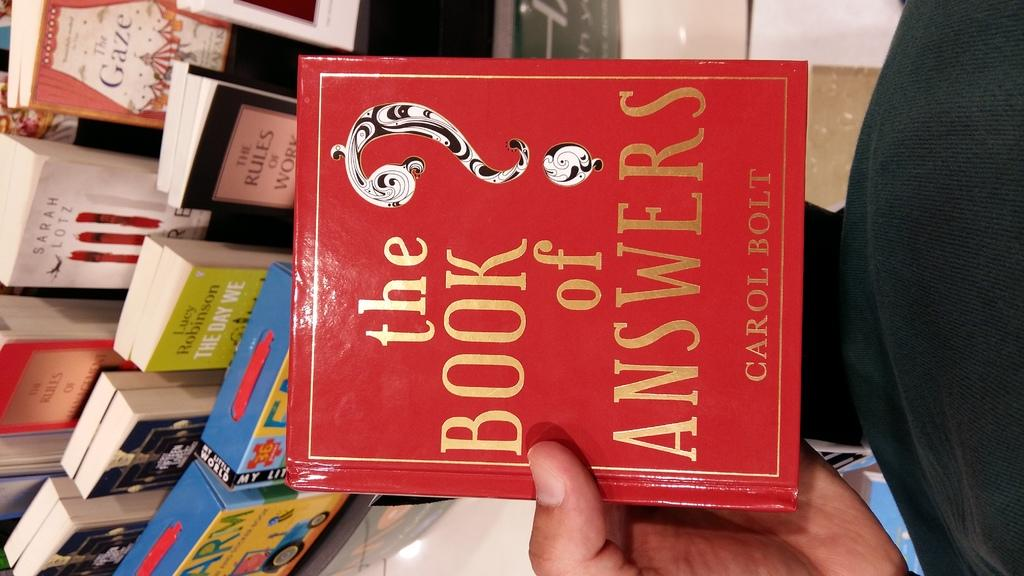<image>
Render a clear and concise summary of the photo. A person holding a book called the book of answers 